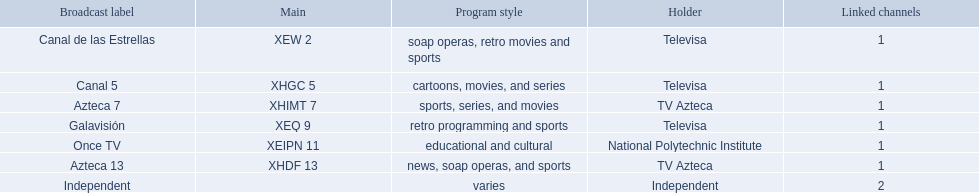Who are the owners of the stations listed here? Televisa, Televisa, TV Azteca, Televisa, National Polytechnic Institute, TV Azteca, Independent. What is the one station owned by national polytechnic institute? Once TV. 